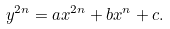<formula> <loc_0><loc_0><loc_500><loc_500>y ^ { 2 n } = a x ^ { 2 n } + b x ^ { n } + c .</formula> 